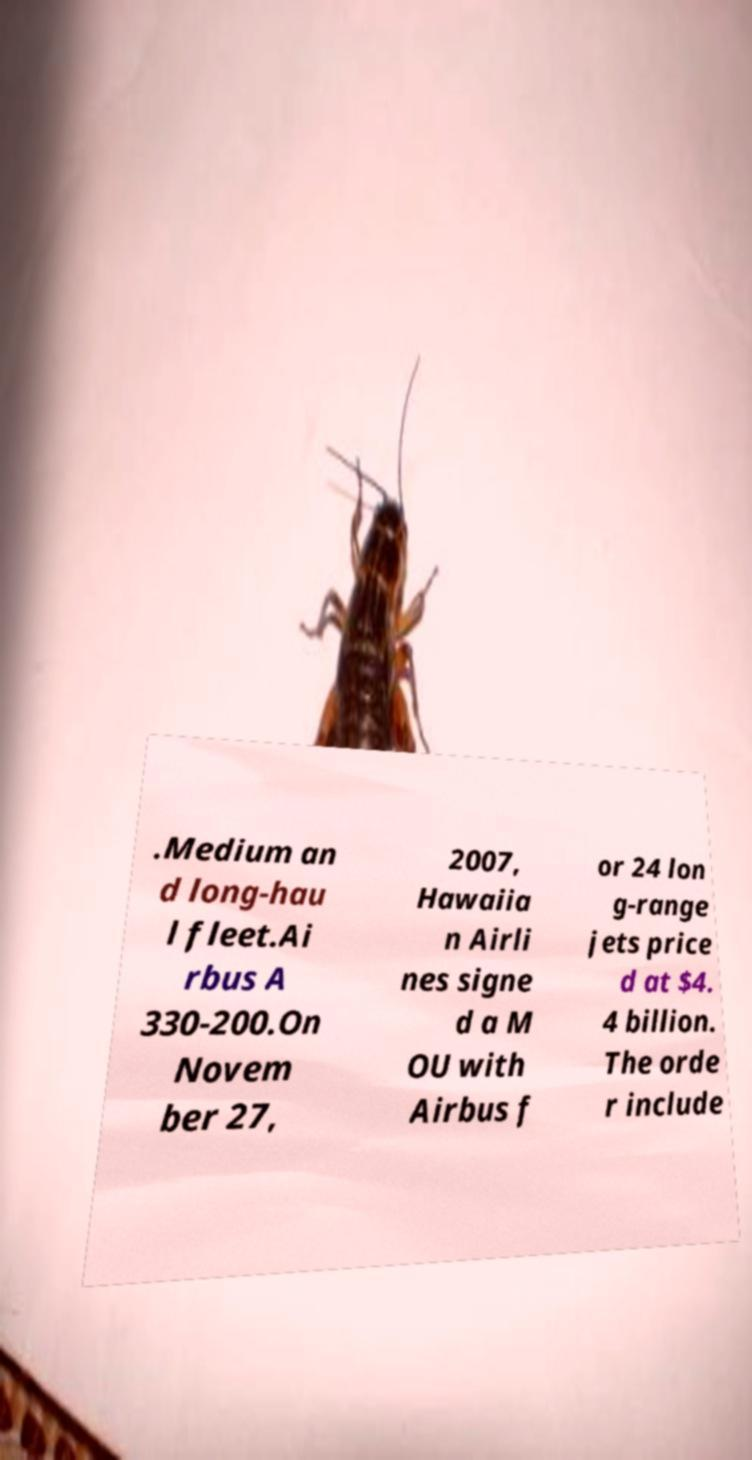I need the written content from this picture converted into text. Can you do that? .Medium an d long-hau l fleet.Ai rbus A 330-200.On Novem ber 27, 2007, Hawaiia n Airli nes signe d a M OU with Airbus f or 24 lon g-range jets price d at $4. 4 billion. The orde r include 